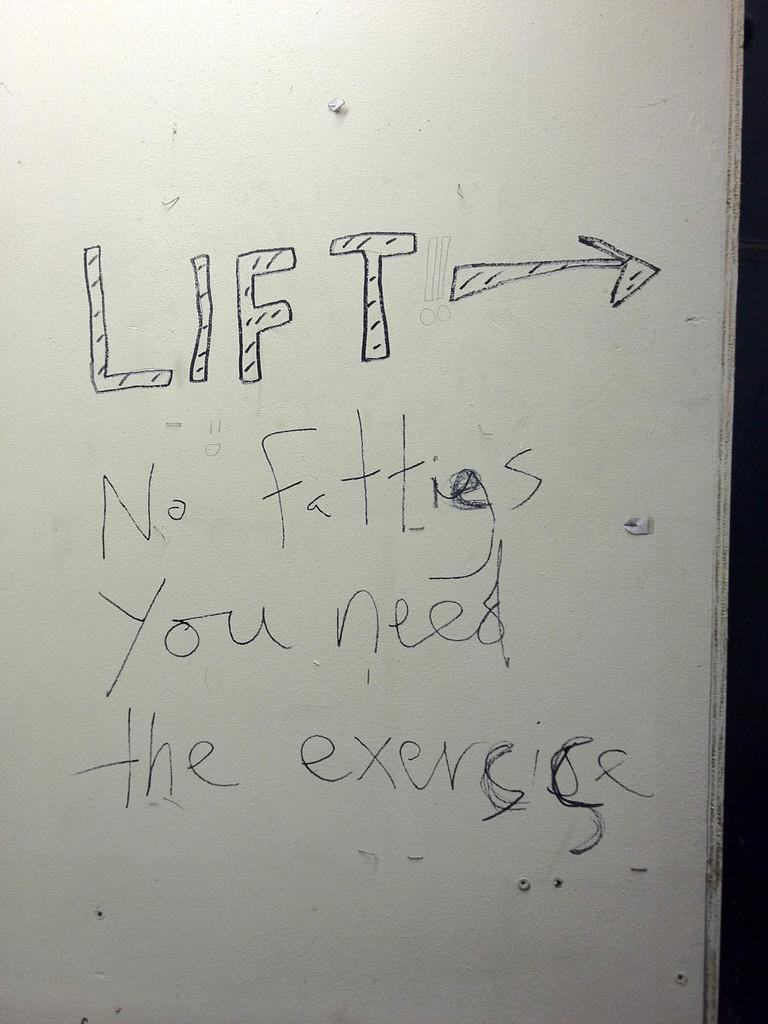<image>
Describe the image concisely. Whiteboard that has the word LIFT on it. 